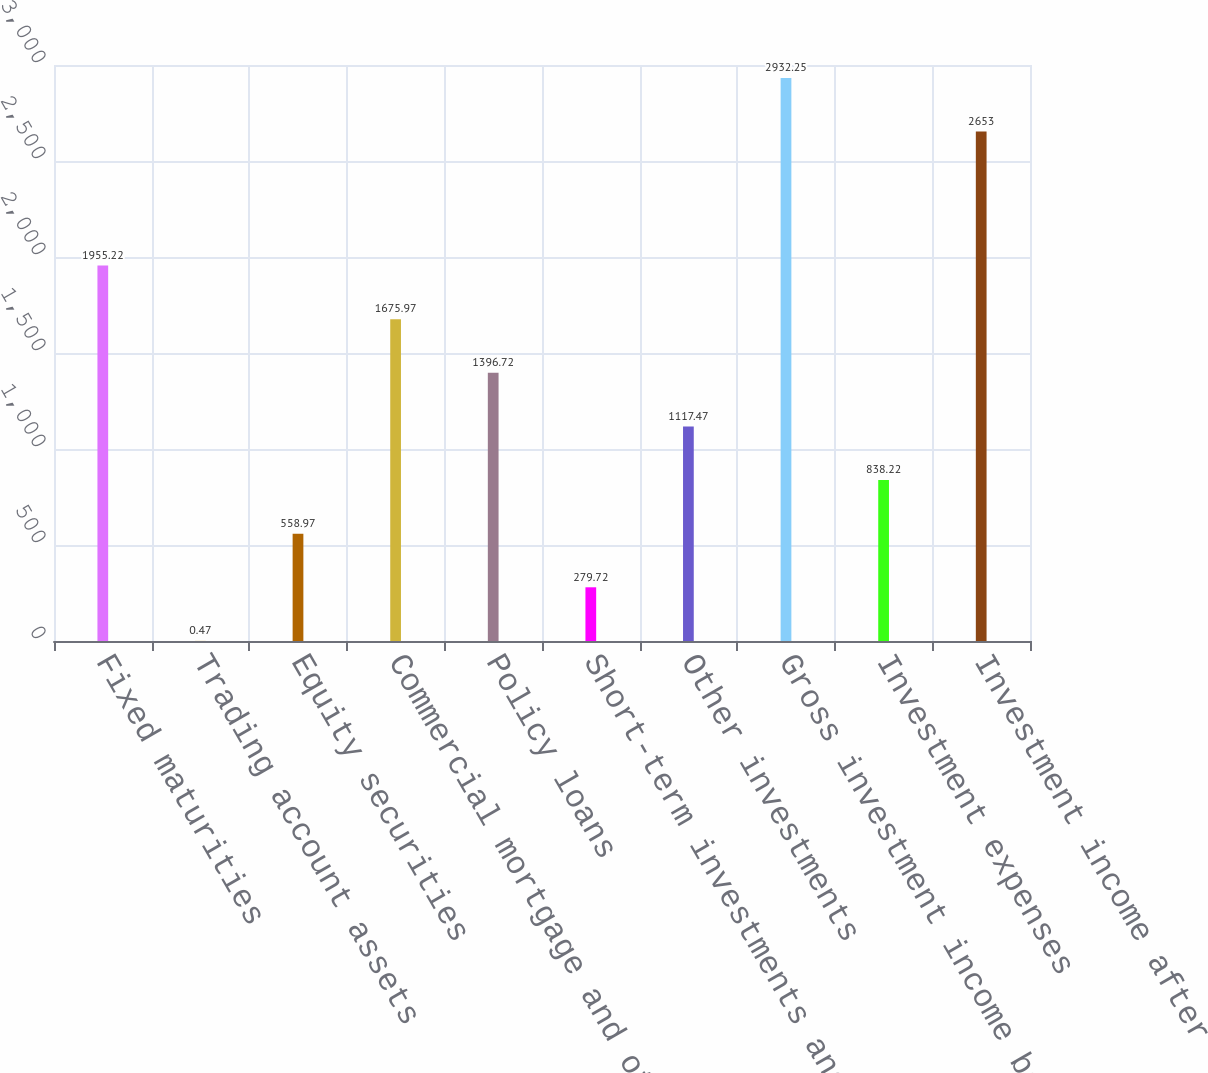<chart> <loc_0><loc_0><loc_500><loc_500><bar_chart><fcel>Fixed maturities<fcel>Trading account assets<fcel>Equity securities<fcel>Commercial mortgage and other<fcel>Policy loans<fcel>Short-term investments and<fcel>Other investments<fcel>Gross investment income before<fcel>Investment expenses<fcel>Investment income after<nl><fcel>1955.22<fcel>0.47<fcel>558.97<fcel>1675.97<fcel>1396.72<fcel>279.72<fcel>1117.47<fcel>2932.25<fcel>838.22<fcel>2653<nl></chart> 